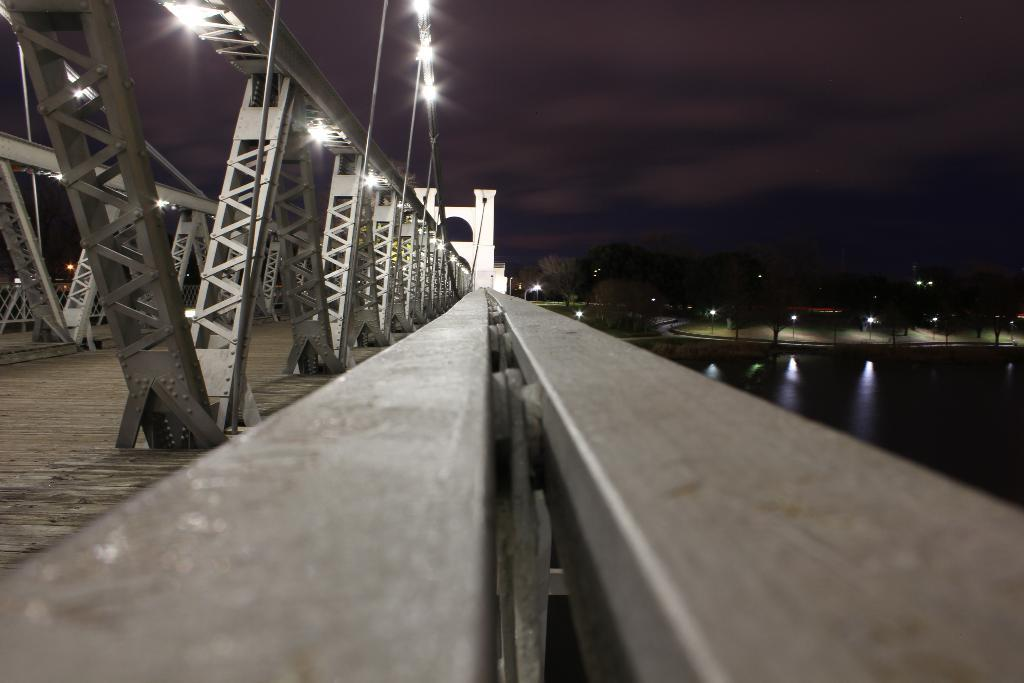What structure is present in the image? There is a bridge in the image. What is the bridge positioned above? The bridge is above a river. What type of vegetation can be seen on the right side of the image? There are trees on the right side of the image. What else is present on the right side of the image? There are lights on the right side of the image. What is visible at the top of the image? The sky is visible at the top of the image. What type of lunch is being served to the children in the image? There are no children or lunch present in the image; it features a bridge above a river with trees, lights, and a visible sky. 